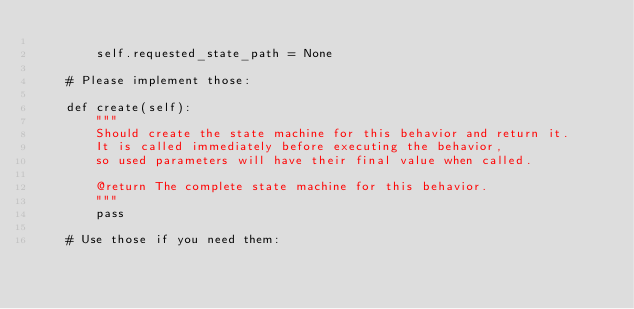Convert code to text. <code><loc_0><loc_0><loc_500><loc_500><_Python_>
        self.requested_state_path = None

    # Please implement those:

    def create(self):
        """
        Should create the state machine for this behavior and return it.
        It is called immediately before executing the behavior,
        so used parameters will have their final value when called.

        @return The complete state machine for this behavior.
        """
        pass

    # Use those if you need them:
</code> 